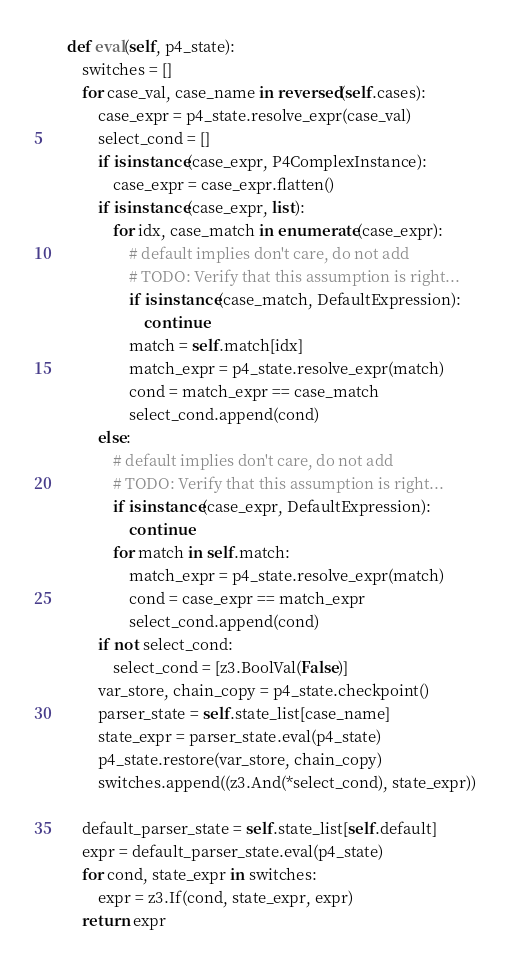<code> <loc_0><loc_0><loc_500><loc_500><_Python_>    def eval(self, p4_state):
        switches = []
        for case_val, case_name in reversed(self.cases):
            case_expr = p4_state.resolve_expr(case_val)
            select_cond = []
            if isinstance(case_expr, P4ComplexInstance):
                case_expr = case_expr.flatten()
            if isinstance(case_expr, list):
                for idx, case_match in enumerate(case_expr):
                    # default implies don't care, do not add
                    # TODO: Verify that this assumption is right...
                    if isinstance(case_match, DefaultExpression):
                        continue
                    match = self.match[idx]
                    match_expr = p4_state.resolve_expr(match)
                    cond = match_expr == case_match
                    select_cond.append(cond)
            else:
                # default implies don't care, do not add
                # TODO: Verify that this assumption is right...
                if isinstance(case_expr, DefaultExpression):
                    continue
                for match in self.match:
                    match_expr = p4_state.resolve_expr(match)
                    cond = case_expr == match_expr
                    select_cond.append(cond)
            if not select_cond:
                select_cond = [z3.BoolVal(False)]
            var_store, chain_copy = p4_state.checkpoint()
            parser_state = self.state_list[case_name]
            state_expr = parser_state.eval(p4_state)
            p4_state.restore(var_store, chain_copy)
            switches.append((z3.And(*select_cond), state_expr))

        default_parser_state = self.state_list[self.default]
        expr = default_parser_state.eval(p4_state)
        for cond, state_expr in switches:
            expr = z3.If(cond, state_expr, expr)
        return expr
</code> 